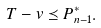<formula> <loc_0><loc_0><loc_500><loc_500>T - v \preceq P ^ { * } _ { n - 1 } .</formula> 